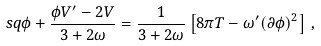Convert formula to latex. <formula><loc_0><loc_0><loc_500><loc_500>\ s q \phi + \frac { \phi V ^ { \prime } - 2 V } { 3 + 2 \omega } = \frac { 1 } { 3 + 2 \omega } \left [ 8 \pi T - \omega ^ { \prime } ( \partial \phi ) ^ { 2 } \right ] \, ,</formula> 